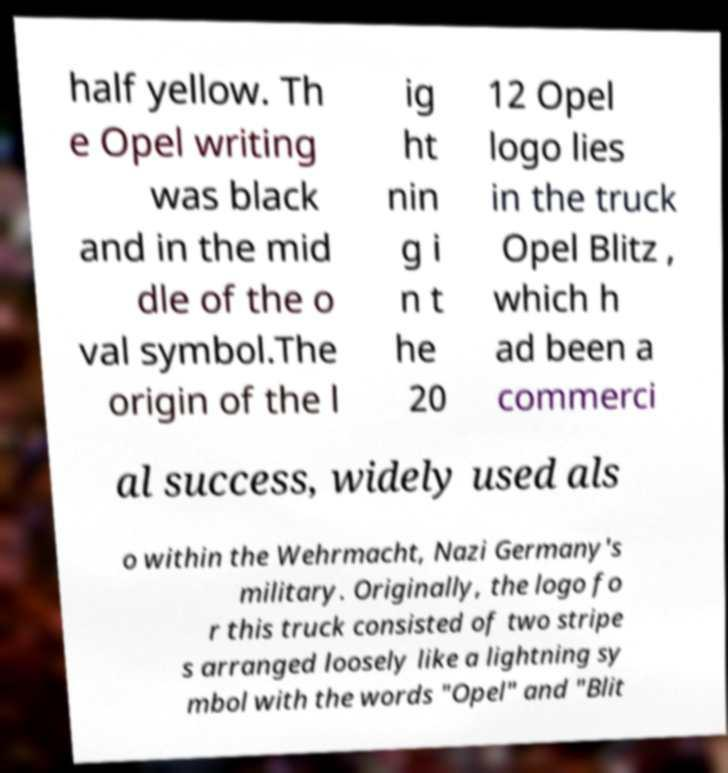I need the written content from this picture converted into text. Can you do that? half yellow. Th e Opel writing was black and in the mid dle of the o val symbol.The origin of the l ig ht nin g i n t he 20 12 Opel logo lies in the truck Opel Blitz , which h ad been a commerci al success, widely used als o within the Wehrmacht, Nazi Germany's military. Originally, the logo fo r this truck consisted of two stripe s arranged loosely like a lightning sy mbol with the words "Opel" and "Blit 